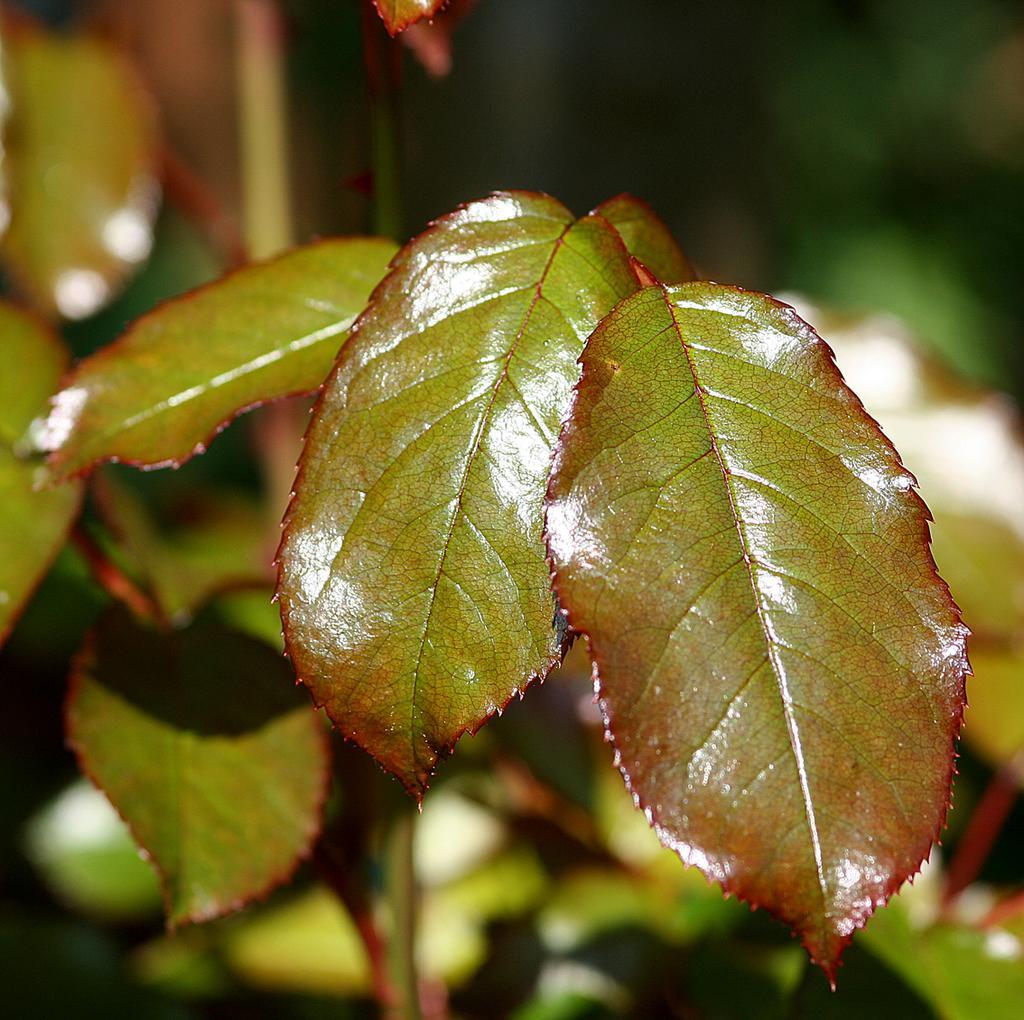How would you summarize this image in a sentence or two? In this picture I can observe leaves in the middle of the picture. The background is blurred. 